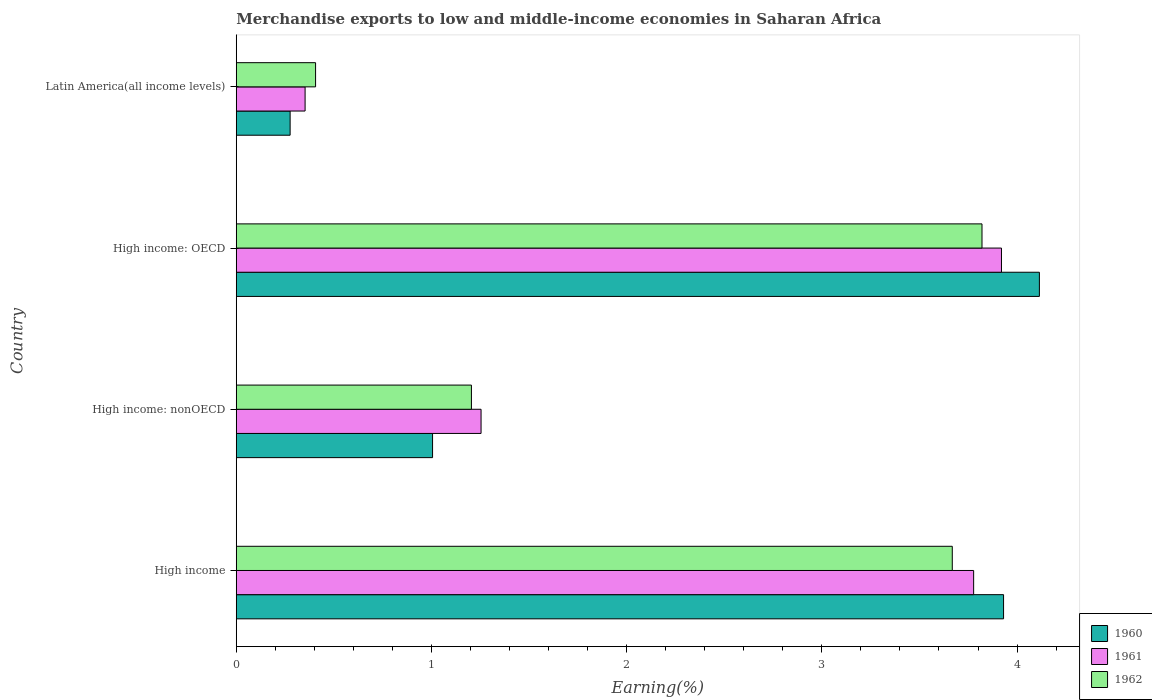How many groups of bars are there?
Make the answer very short. 4. How many bars are there on the 1st tick from the top?
Provide a short and direct response. 3. How many bars are there on the 2nd tick from the bottom?
Offer a terse response. 3. What is the label of the 3rd group of bars from the top?
Make the answer very short. High income: nonOECD. In how many cases, is the number of bars for a given country not equal to the number of legend labels?
Your answer should be very brief. 0. What is the percentage of amount earned from merchandise exports in 1960 in High income: nonOECD?
Ensure brevity in your answer.  1.01. Across all countries, what is the maximum percentage of amount earned from merchandise exports in 1961?
Your answer should be compact. 3.92. Across all countries, what is the minimum percentage of amount earned from merchandise exports in 1960?
Offer a very short reply. 0.28. In which country was the percentage of amount earned from merchandise exports in 1962 maximum?
Offer a terse response. High income: OECD. In which country was the percentage of amount earned from merchandise exports in 1960 minimum?
Ensure brevity in your answer.  Latin America(all income levels). What is the total percentage of amount earned from merchandise exports in 1962 in the graph?
Give a very brief answer. 9.1. What is the difference between the percentage of amount earned from merchandise exports in 1961 in High income: OECD and that in Latin America(all income levels)?
Give a very brief answer. 3.57. What is the difference between the percentage of amount earned from merchandise exports in 1960 in High income: OECD and the percentage of amount earned from merchandise exports in 1962 in High income: nonOECD?
Provide a succinct answer. 2.91. What is the average percentage of amount earned from merchandise exports in 1962 per country?
Give a very brief answer. 2.27. What is the difference between the percentage of amount earned from merchandise exports in 1962 and percentage of amount earned from merchandise exports in 1961 in High income?
Give a very brief answer. -0.11. In how many countries, is the percentage of amount earned from merchandise exports in 1960 greater than 2.4 %?
Provide a succinct answer. 2. What is the ratio of the percentage of amount earned from merchandise exports in 1960 in High income to that in High income: OECD?
Offer a very short reply. 0.96. Is the difference between the percentage of amount earned from merchandise exports in 1962 in High income: OECD and Latin America(all income levels) greater than the difference between the percentage of amount earned from merchandise exports in 1961 in High income: OECD and Latin America(all income levels)?
Give a very brief answer. No. What is the difference between the highest and the second highest percentage of amount earned from merchandise exports in 1962?
Ensure brevity in your answer.  0.15. What is the difference between the highest and the lowest percentage of amount earned from merchandise exports in 1960?
Offer a very short reply. 3.84. In how many countries, is the percentage of amount earned from merchandise exports in 1961 greater than the average percentage of amount earned from merchandise exports in 1961 taken over all countries?
Offer a very short reply. 2. Is the sum of the percentage of amount earned from merchandise exports in 1961 in High income and Latin America(all income levels) greater than the maximum percentage of amount earned from merchandise exports in 1960 across all countries?
Keep it short and to the point. Yes. What does the 1st bar from the bottom in High income represents?
Give a very brief answer. 1960. How many bars are there?
Your response must be concise. 12. Are the values on the major ticks of X-axis written in scientific E-notation?
Offer a terse response. No. Does the graph contain any zero values?
Your response must be concise. No. Does the graph contain grids?
Your response must be concise. No. Where does the legend appear in the graph?
Give a very brief answer. Bottom right. How many legend labels are there?
Ensure brevity in your answer.  3. How are the legend labels stacked?
Provide a succinct answer. Vertical. What is the title of the graph?
Provide a short and direct response. Merchandise exports to low and middle-income economies in Saharan Africa. Does "2006" appear as one of the legend labels in the graph?
Offer a terse response. No. What is the label or title of the X-axis?
Ensure brevity in your answer.  Earning(%). What is the Earning(%) in 1960 in High income?
Ensure brevity in your answer.  3.93. What is the Earning(%) of 1961 in High income?
Your response must be concise. 3.78. What is the Earning(%) of 1962 in High income?
Ensure brevity in your answer.  3.67. What is the Earning(%) of 1960 in High income: nonOECD?
Your answer should be compact. 1.01. What is the Earning(%) in 1961 in High income: nonOECD?
Offer a terse response. 1.25. What is the Earning(%) in 1962 in High income: nonOECD?
Keep it short and to the point. 1.2. What is the Earning(%) in 1960 in High income: OECD?
Your response must be concise. 4.11. What is the Earning(%) in 1961 in High income: OECD?
Offer a very short reply. 3.92. What is the Earning(%) in 1962 in High income: OECD?
Your answer should be very brief. 3.82. What is the Earning(%) of 1960 in Latin America(all income levels)?
Offer a terse response. 0.28. What is the Earning(%) in 1961 in Latin America(all income levels)?
Your response must be concise. 0.35. What is the Earning(%) in 1962 in Latin America(all income levels)?
Your answer should be compact. 0.41. Across all countries, what is the maximum Earning(%) in 1960?
Offer a very short reply. 4.11. Across all countries, what is the maximum Earning(%) of 1961?
Provide a short and direct response. 3.92. Across all countries, what is the maximum Earning(%) of 1962?
Make the answer very short. 3.82. Across all countries, what is the minimum Earning(%) of 1960?
Provide a short and direct response. 0.28. Across all countries, what is the minimum Earning(%) in 1961?
Give a very brief answer. 0.35. Across all countries, what is the minimum Earning(%) of 1962?
Keep it short and to the point. 0.41. What is the total Earning(%) in 1960 in the graph?
Your response must be concise. 9.33. What is the total Earning(%) in 1961 in the graph?
Make the answer very short. 9.3. What is the total Earning(%) in 1962 in the graph?
Provide a succinct answer. 9.1. What is the difference between the Earning(%) in 1960 in High income and that in High income: nonOECD?
Make the answer very short. 2.93. What is the difference between the Earning(%) of 1961 in High income and that in High income: nonOECD?
Keep it short and to the point. 2.52. What is the difference between the Earning(%) of 1962 in High income and that in High income: nonOECD?
Offer a very short reply. 2.46. What is the difference between the Earning(%) of 1960 in High income and that in High income: OECD?
Your answer should be compact. -0.18. What is the difference between the Earning(%) of 1961 in High income and that in High income: OECD?
Keep it short and to the point. -0.14. What is the difference between the Earning(%) of 1962 in High income and that in High income: OECD?
Provide a succinct answer. -0.15. What is the difference between the Earning(%) of 1960 in High income and that in Latin America(all income levels)?
Provide a short and direct response. 3.65. What is the difference between the Earning(%) in 1961 in High income and that in Latin America(all income levels)?
Your answer should be very brief. 3.42. What is the difference between the Earning(%) of 1962 in High income and that in Latin America(all income levels)?
Offer a very short reply. 3.26. What is the difference between the Earning(%) in 1960 in High income: nonOECD and that in High income: OECD?
Offer a very short reply. -3.11. What is the difference between the Earning(%) in 1961 in High income: nonOECD and that in High income: OECD?
Your response must be concise. -2.67. What is the difference between the Earning(%) of 1962 in High income: nonOECD and that in High income: OECD?
Offer a very short reply. -2.62. What is the difference between the Earning(%) of 1960 in High income: nonOECD and that in Latin America(all income levels)?
Your response must be concise. 0.73. What is the difference between the Earning(%) in 1961 in High income: nonOECD and that in Latin America(all income levels)?
Your answer should be compact. 0.9. What is the difference between the Earning(%) in 1962 in High income: nonOECD and that in Latin America(all income levels)?
Offer a terse response. 0.8. What is the difference between the Earning(%) of 1960 in High income: OECD and that in Latin America(all income levels)?
Offer a very short reply. 3.84. What is the difference between the Earning(%) of 1961 in High income: OECD and that in Latin America(all income levels)?
Offer a very short reply. 3.57. What is the difference between the Earning(%) in 1962 in High income: OECD and that in Latin America(all income levels)?
Your response must be concise. 3.41. What is the difference between the Earning(%) of 1960 in High income and the Earning(%) of 1961 in High income: nonOECD?
Provide a succinct answer. 2.68. What is the difference between the Earning(%) in 1960 in High income and the Earning(%) in 1962 in High income: nonOECD?
Your response must be concise. 2.73. What is the difference between the Earning(%) of 1961 in High income and the Earning(%) of 1962 in High income: nonOECD?
Provide a succinct answer. 2.57. What is the difference between the Earning(%) in 1960 in High income and the Earning(%) in 1961 in High income: OECD?
Keep it short and to the point. 0.01. What is the difference between the Earning(%) of 1960 in High income and the Earning(%) of 1962 in High income: OECD?
Make the answer very short. 0.11. What is the difference between the Earning(%) in 1961 in High income and the Earning(%) in 1962 in High income: OECD?
Make the answer very short. -0.04. What is the difference between the Earning(%) in 1960 in High income and the Earning(%) in 1961 in Latin America(all income levels)?
Ensure brevity in your answer.  3.58. What is the difference between the Earning(%) in 1960 in High income and the Earning(%) in 1962 in Latin America(all income levels)?
Offer a very short reply. 3.52. What is the difference between the Earning(%) of 1961 in High income and the Earning(%) of 1962 in Latin America(all income levels)?
Ensure brevity in your answer.  3.37. What is the difference between the Earning(%) in 1960 in High income: nonOECD and the Earning(%) in 1961 in High income: OECD?
Provide a succinct answer. -2.91. What is the difference between the Earning(%) in 1960 in High income: nonOECD and the Earning(%) in 1962 in High income: OECD?
Your answer should be compact. -2.81. What is the difference between the Earning(%) of 1961 in High income: nonOECD and the Earning(%) of 1962 in High income: OECD?
Provide a succinct answer. -2.57. What is the difference between the Earning(%) of 1960 in High income: nonOECD and the Earning(%) of 1961 in Latin America(all income levels)?
Ensure brevity in your answer.  0.65. What is the difference between the Earning(%) of 1960 in High income: nonOECD and the Earning(%) of 1962 in Latin America(all income levels)?
Your answer should be very brief. 0.6. What is the difference between the Earning(%) in 1961 in High income: nonOECD and the Earning(%) in 1962 in Latin America(all income levels)?
Ensure brevity in your answer.  0.85. What is the difference between the Earning(%) in 1960 in High income: OECD and the Earning(%) in 1961 in Latin America(all income levels)?
Make the answer very short. 3.76. What is the difference between the Earning(%) of 1960 in High income: OECD and the Earning(%) of 1962 in Latin America(all income levels)?
Provide a succinct answer. 3.71. What is the difference between the Earning(%) of 1961 in High income: OECD and the Earning(%) of 1962 in Latin America(all income levels)?
Ensure brevity in your answer.  3.51. What is the average Earning(%) in 1960 per country?
Give a very brief answer. 2.33. What is the average Earning(%) in 1961 per country?
Your answer should be compact. 2.33. What is the average Earning(%) of 1962 per country?
Offer a very short reply. 2.27. What is the difference between the Earning(%) of 1960 and Earning(%) of 1961 in High income?
Ensure brevity in your answer.  0.15. What is the difference between the Earning(%) of 1960 and Earning(%) of 1962 in High income?
Keep it short and to the point. 0.26. What is the difference between the Earning(%) of 1961 and Earning(%) of 1962 in High income?
Ensure brevity in your answer.  0.11. What is the difference between the Earning(%) of 1960 and Earning(%) of 1961 in High income: nonOECD?
Ensure brevity in your answer.  -0.25. What is the difference between the Earning(%) in 1960 and Earning(%) in 1962 in High income: nonOECD?
Provide a short and direct response. -0.2. What is the difference between the Earning(%) of 1961 and Earning(%) of 1962 in High income: nonOECD?
Make the answer very short. 0.05. What is the difference between the Earning(%) in 1960 and Earning(%) in 1961 in High income: OECD?
Your answer should be compact. 0.19. What is the difference between the Earning(%) of 1960 and Earning(%) of 1962 in High income: OECD?
Your answer should be compact. 0.29. What is the difference between the Earning(%) of 1961 and Earning(%) of 1962 in High income: OECD?
Keep it short and to the point. 0.1. What is the difference between the Earning(%) in 1960 and Earning(%) in 1961 in Latin America(all income levels)?
Make the answer very short. -0.08. What is the difference between the Earning(%) of 1960 and Earning(%) of 1962 in Latin America(all income levels)?
Ensure brevity in your answer.  -0.13. What is the difference between the Earning(%) of 1961 and Earning(%) of 1962 in Latin America(all income levels)?
Make the answer very short. -0.05. What is the ratio of the Earning(%) of 1960 in High income to that in High income: nonOECD?
Make the answer very short. 3.91. What is the ratio of the Earning(%) of 1961 in High income to that in High income: nonOECD?
Your response must be concise. 3.01. What is the ratio of the Earning(%) in 1962 in High income to that in High income: nonOECD?
Keep it short and to the point. 3.04. What is the ratio of the Earning(%) of 1960 in High income to that in High income: OECD?
Your answer should be very brief. 0.96. What is the ratio of the Earning(%) in 1961 in High income to that in High income: OECD?
Your response must be concise. 0.96. What is the ratio of the Earning(%) in 1962 in High income to that in High income: OECD?
Keep it short and to the point. 0.96. What is the ratio of the Earning(%) in 1960 in High income to that in Latin America(all income levels)?
Provide a short and direct response. 14.24. What is the ratio of the Earning(%) of 1961 in High income to that in Latin America(all income levels)?
Your answer should be compact. 10.71. What is the ratio of the Earning(%) of 1962 in High income to that in Latin America(all income levels)?
Your response must be concise. 9.03. What is the ratio of the Earning(%) of 1960 in High income: nonOECD to that in High income: OECD?
Your answer should be very brief. 0.24. What is the ratio of the Earning(%) of 1961 in High income: nonOECD to that in High income: OECD?
Make the answer very short. 0.32. What is the ratio of the Earning(%) in 1962 in High income: nonOECD to that in High income: OECD?
Your response must be concise. 0.32. What is the ratio of the Earning(%) of 1960 in High income: nonOECD to that in Latin America(all income levels)?
Make the answer very short. 3.64. What is the ratio of the Earning(%) in 1961 in High income: nonOECD to that in Latin America(all income levels)?
Your response must be concise. 3.56. What is the ratio of the Earning(%) of 1962 in High income: nonOECD to that in Latin America(all income levels)?
Provide a short and direct response. 2.96. What is the ratio of the Earning(%) of 1960 in High income: OECD to that in Latin America(all income levels)?
Your answer should be very brief. 14.91. What is the ratio of the Earning(%) in 1961 in High income: OECD to that in Latin America(all income levels)?
Offer a terse response. 11.11. What is the ratio of the Earning(%) of 1962 in High income: OECD to that in Latin America(all income levels)?
Your response must be concise. 9.4. What is the difference between the highest and the second highest Earning(%) in 1960?
Ensure brevity in your answer.  0.18. What is the difference between the highest and the second highest Earning(%) of 1961?
Provide a succinct answer. 0.14. What is the difference between the highest and the second highest Earning(%) in 1962?
Offer a very short reply. 0.15. What is the difference between the highest and the lowest Earning(%) in 1960?
Give a very brief answer. 3.84. What is the difference between the highest and the lowest Earning(%) in 1961?
Provide a short and direct response. 3.57. What is the difference between the highest and the lowest Earning(%) of 1962?
Give a very brief answer. 3.41. 